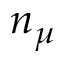<formula> <loc_0><loc_0><loc_500><loc_500>n _ { \mu }</formula> 